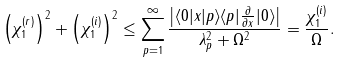<formula> <loc_0><loc_0><loc_500><loc_500>\left ( \chi _ { 1 } ^ { ( r ) } \right ) ^ { 2 } + \left ( \chi _ { 1 } ^ { ( i ) } \right ) ^ { 2 } \leq \sum _ { p = 1 } ^ { \infty } \frac { \left | \langle 0 | x | p \rangle \langle p | \frac { \partial } { \partial x } | 0 \rangle \right | } { \lambda _ { p } ^ { 2 } + \Omega ^ { 2 } } = \frac { \chi _ { 1 } ^ { ( i ) } } { \Omega } .</formula> 